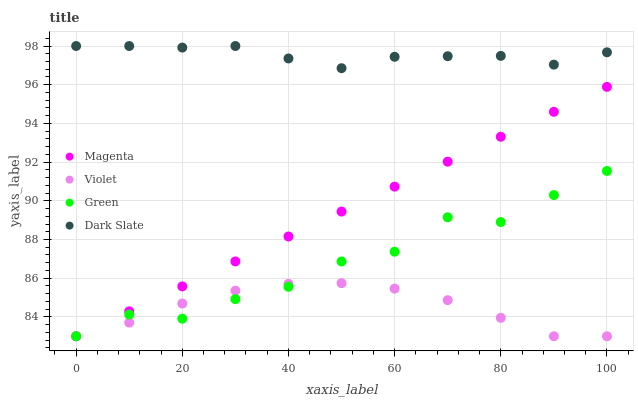Does Violet have the minimum area under the curve?
Answer yes or no. Yes. Does Dark Slate have the maximum area under the curve?
Answer yes or no. Yes. Does Magenta have the minimum area under the curve?
Answer yes or no. No. Does Magenta have the maximum area under the curve?
Answer yes or no. No. Is Magenta the smoothest?
Answer yes or no. Yes. Is Green the roughest?
Answer yes or no. Yes. Is Green the smoothest?
Answer yes or no. No. Is Magenta the roughest?
Answer yes or no. No. Does Magenta have the lowest value?
Answer yes or no. Yes. Does Dark Slate have the highest value?
Answer yes or no. Yes. Does Magenta have the highest value?
Answer yes or no. No. Is Magenta less than Dark Slate?
Answer yes or no. Yes. Is Dark Slate greater than Green?
Answer yes or no. Yes. Does Violet intersect Green?
Answer yes or no. Yes. Is Violet less than Green?
Answer yes or no. No. Is Violet greater than Green?
Answer yes or no. No. Does Magenta intersect Dark Slate?
Answer yes or no. No. 